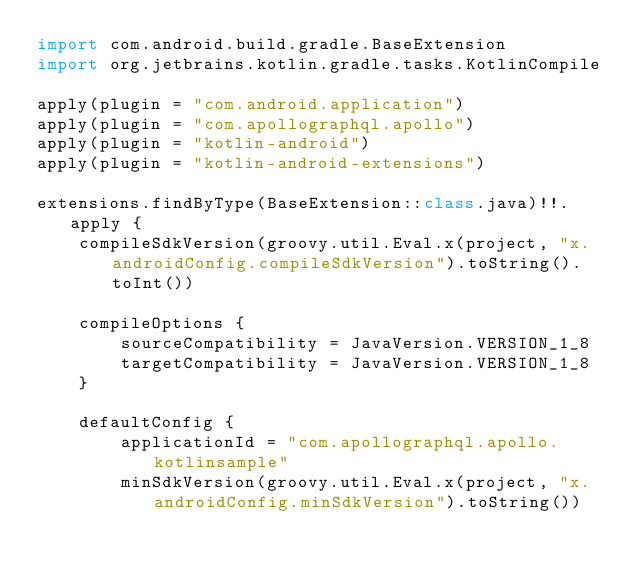<code> <loc_0><loc_0><loc_500><loc_500><_Kotlin_>import com.android.build.gradle.BaseExtension
import org.jetbrains.kotlin.gradle.tasks.KotlinCompile

apply(plugin = "com.android.application")
apply(plugin = "com.apollographql.apollo")
apply(plugin = "kotlin-android")
apply(plugin = "kotlin-android-extensions")

extensions.findByType(BaseExtension::class.java)!!.apply {
    compileSdkVersion(groovy.util.Eval.x(project, "x.androidConfig.compileSdkVersion").toString().toInt())

    compileOptions {
        sourceCompatibility = JavaVersion.VERSION_1_8
        targetCompatibility = JavaVersion.VERSION_1_8
    }

    defaultConfig {
        applicationId = "com.apollographql.apollo.kotlinsample"
        minSdkVersion(groovy.util.Eval.x(project, "x.androidConfig.minSdkVersion").toString())</code> 